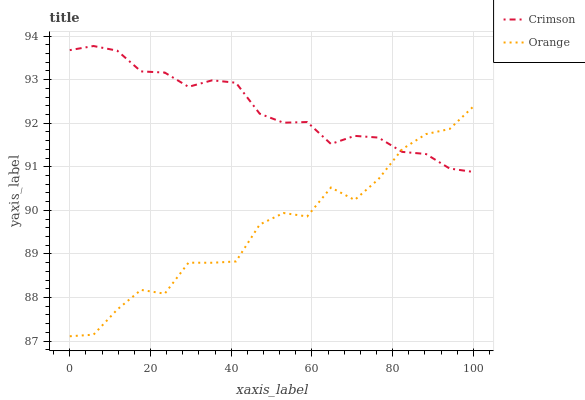Does Orange have the maximum area under the curve?
Answer yes or no. No. Is Orange the smoothest?
Answer yes or no. No. Does Orange have the highest value?
Answer yes or no. No. 